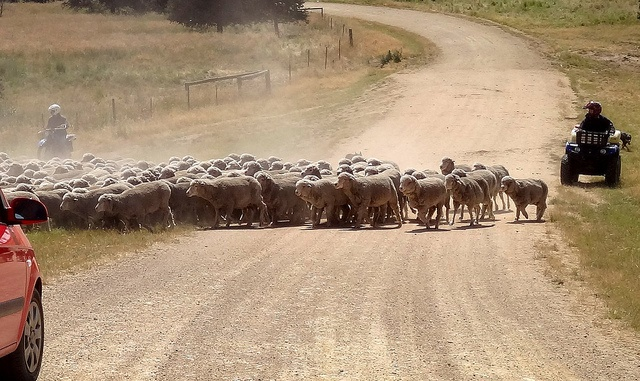Describe the objects in this image and their specific colors. I can see sheep in black, lightgray, darkgray, and tan tones, car in black, brown, maroon, and gray tones, sheep in black, maroon, and gray tones, sheep in black, maroon, and gray tones, and sheep in black, maroon, and gray tones in this image. 